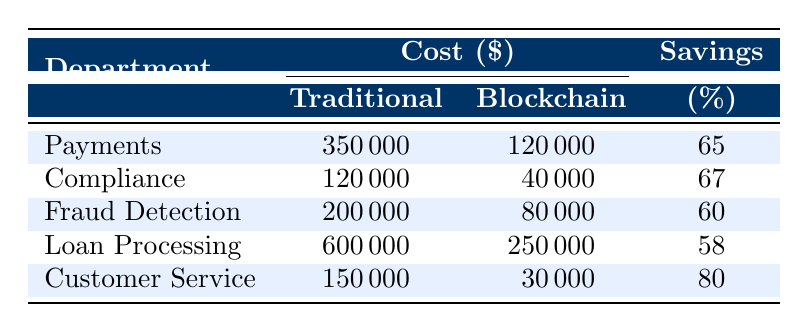What is the cost saving for Loan Processing using traditional systems? The table shows the cost saving for Loan Processing under traditional systems, which is directly listed as 600000.
Answer: 600000 What percentage of cost savings does Customer Service achieve with blockchain systems? The table indicates that Customer Service savings percentage when using blockchain systems is given as 80.
Answer: 80 What is the total cost saving difference between traditional systems and blockchain systems across all departments? First, we calculate the total savings for traditional systems: 350000 + 120000 + 200000 + 600000 + 150000 = 1520000. Then, we calculate the total savings for blockchain systems: 120000 + 40000 + 80000 + 250000 + 30000 = 500000. Therefore, the difference is 1520000 - 500000 = 1020000.
Answer: 1020000 Is the cost saving percentage for Fraud Detection higher than for Loan Processing? The cost saving percentage for Fraud Detection is listed as 60, while for Loan Processing it is 58. Since 60 is greater than 58, the statement is true.
Answer: Yes Which department has the highest cost savings when implementing traditional systems? By examining the table, Loan Processing is listed with the highest traditional system savings of 600000 compared to all other departments' traditional savings.
Answer: Loan Processing What is the average cost savings percentage for all departments using blockchain systems? The percentages are 65 for Payments, 67 for Compliance, 60 for Fraud Detection, 58 for Loan Processing, and 80 for Customer Service. To find the average: (65 + 67 + 60 + 58 + 80) / 5 = 66.
Answer: 66 Which department shows the least cost savings when using blockchain systems? Comparing the cost savings for blockchain systems, the values are 120000 for Payments, 40000 for Compliance, 80000 for Fraud Detection, 250000 for Loan Processing, and 30000 for Customer Service. The lowest amount is for Customer Service at 30000.
Answer: Customer Service Is the cost saving for traditional systems in the Payments department more than in Compliance? The cost effect for Payments is 350000 and for Compliance is 120000; since 350000 is greater than 120000, the statement is true.
Answer: Yes What total savings is achieved for Compliance in both traditional and blockchain systems? Traditional system savings for Compliance is 120000 and for blockchain systems, it's 40000. The total savings is 120000 + 40000 = 160000.
Answer: 160000 